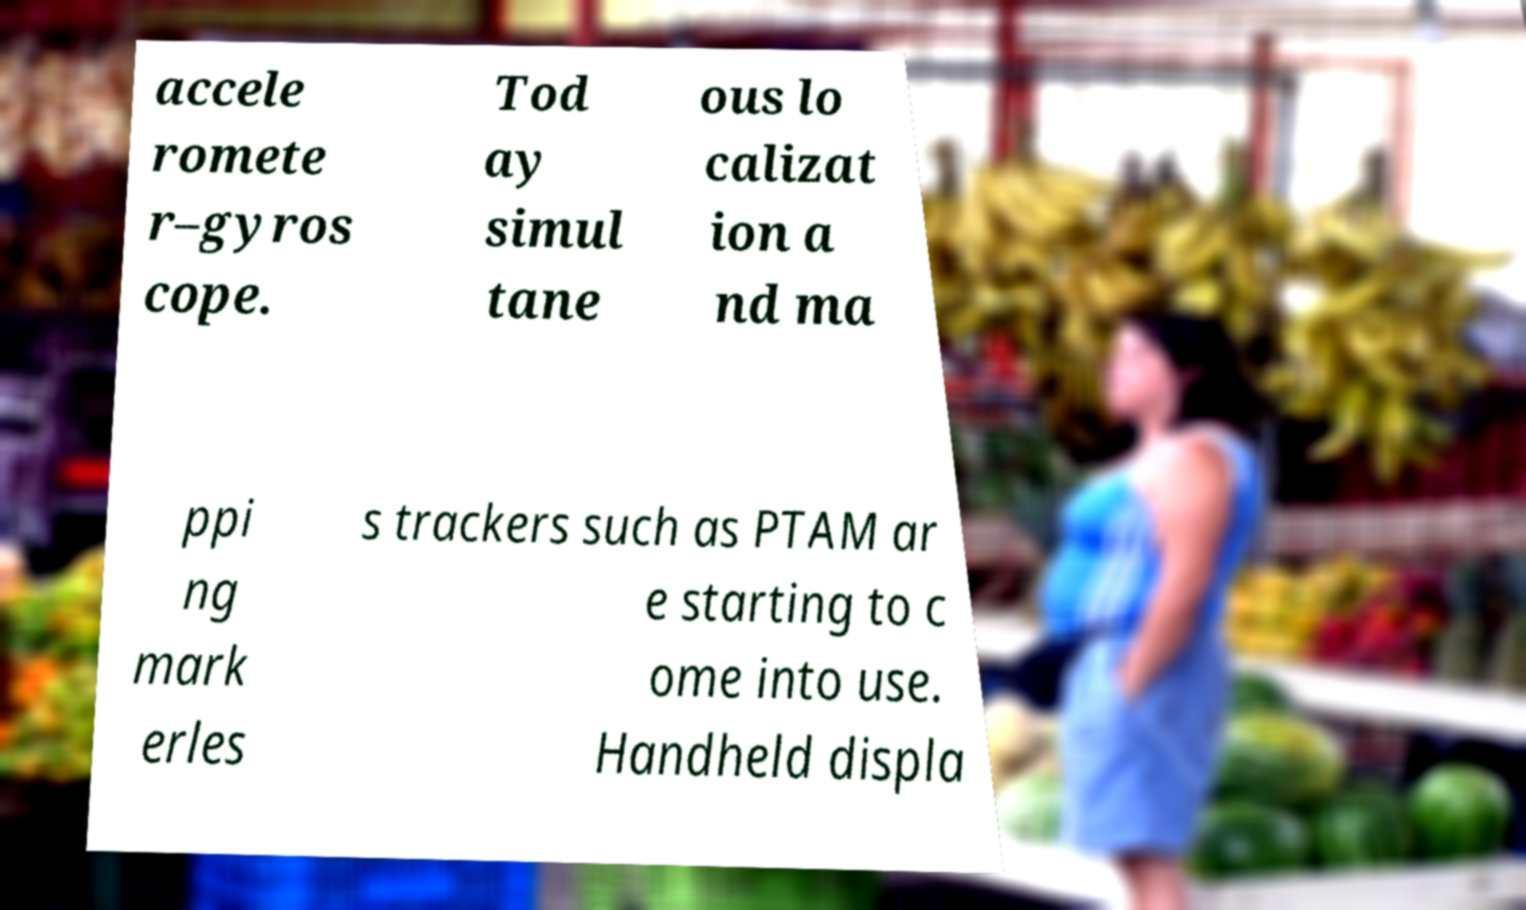For documentation purposes, I need the text within this image transcribed. Could you provide that? accele romete r–gyros cope. Tod ay simul tane ous lo calizat ion a nd ma ppi ng mark erles s trackers such as PTAM ar e starting to c ome into use. Handheld displa 